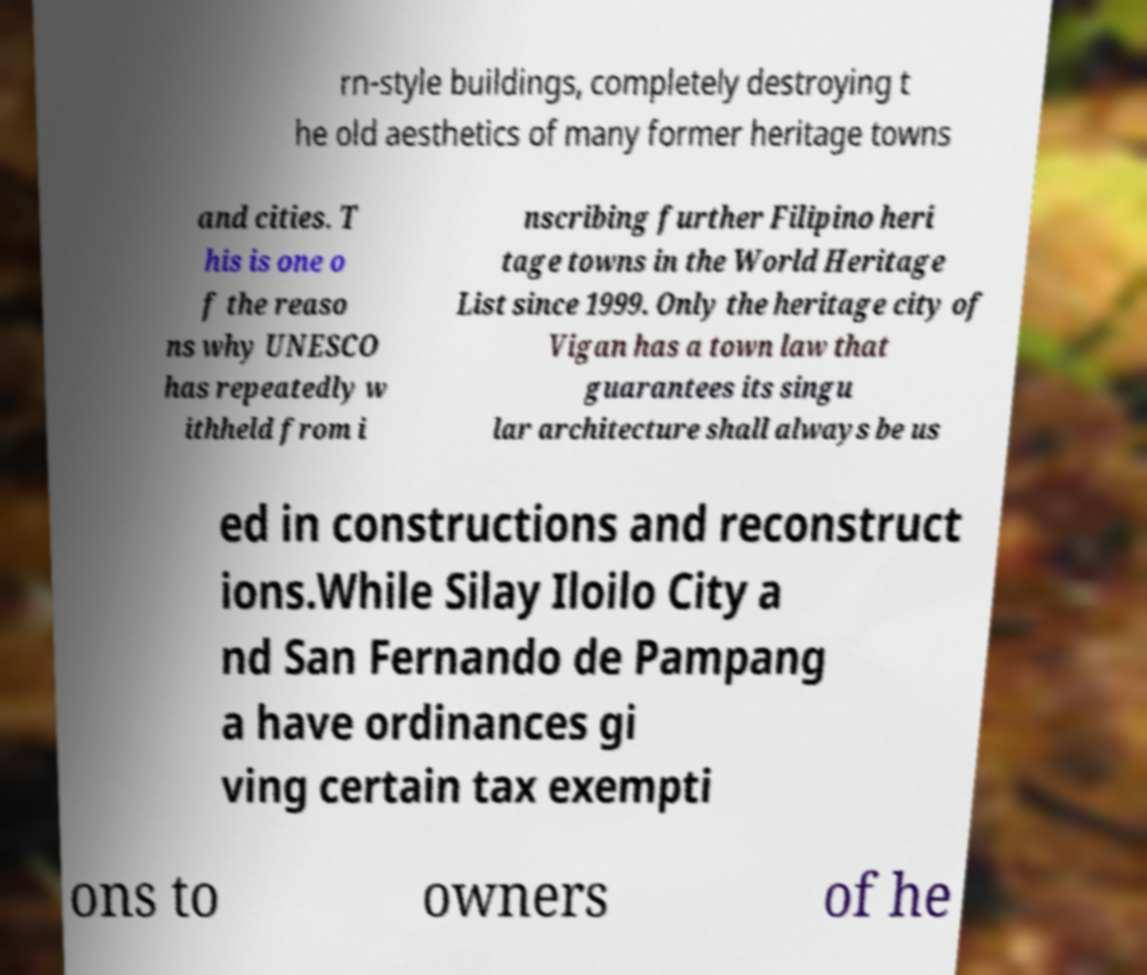Please read and relay the text visible in this image. What does it say? rn-style buildings, completely destroying t he old aesthetics of many former heritage towns and cities. T his is one o f the reaso ns why UNESCO has repeatedly w ithheld from i nscribing further Filipino heri tage towns in the World Heritage List since 1999. Only the heritage city of Vigan has a town law that guarantees its singu lar architecture shall always be us ed in constructions and reconstruct ions.While Silay Iloilo City a nd San Fernando de Pampang a have ordinances gi ving certain tax exempti ons to owners of he 